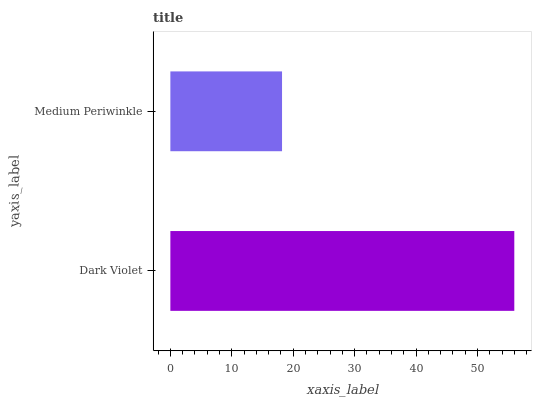Is Medium Periwinkle the minimum?
Answer yes or no. Yes. Is Dark Violet the maximum?
Answer yes or no. Yes. Is Medium Periwinkle the maximum?
Answer yes or no. No. Is Dark Violet greater than Medium Periwinkle?
Answer yes or no. Yes. Is Medium Periwinkle less than Dark Violet?
Answer yes or no. Yes. Is Medium Periwinkle greater than Dark Violet?
Answer yes or no. No. Is Dark Violet less than Medium Periwinkle?
Answer yes or no. No. Is Dark Violet the high median?
Answer yes or no. Yes. Is Medium Periwinkle the low median?
Answer yes or no. Yes. Is Medium Periwinkle the high median?
Answer yes or no. No. Is Dark Violet the low median?
Answer yes or no. No. 